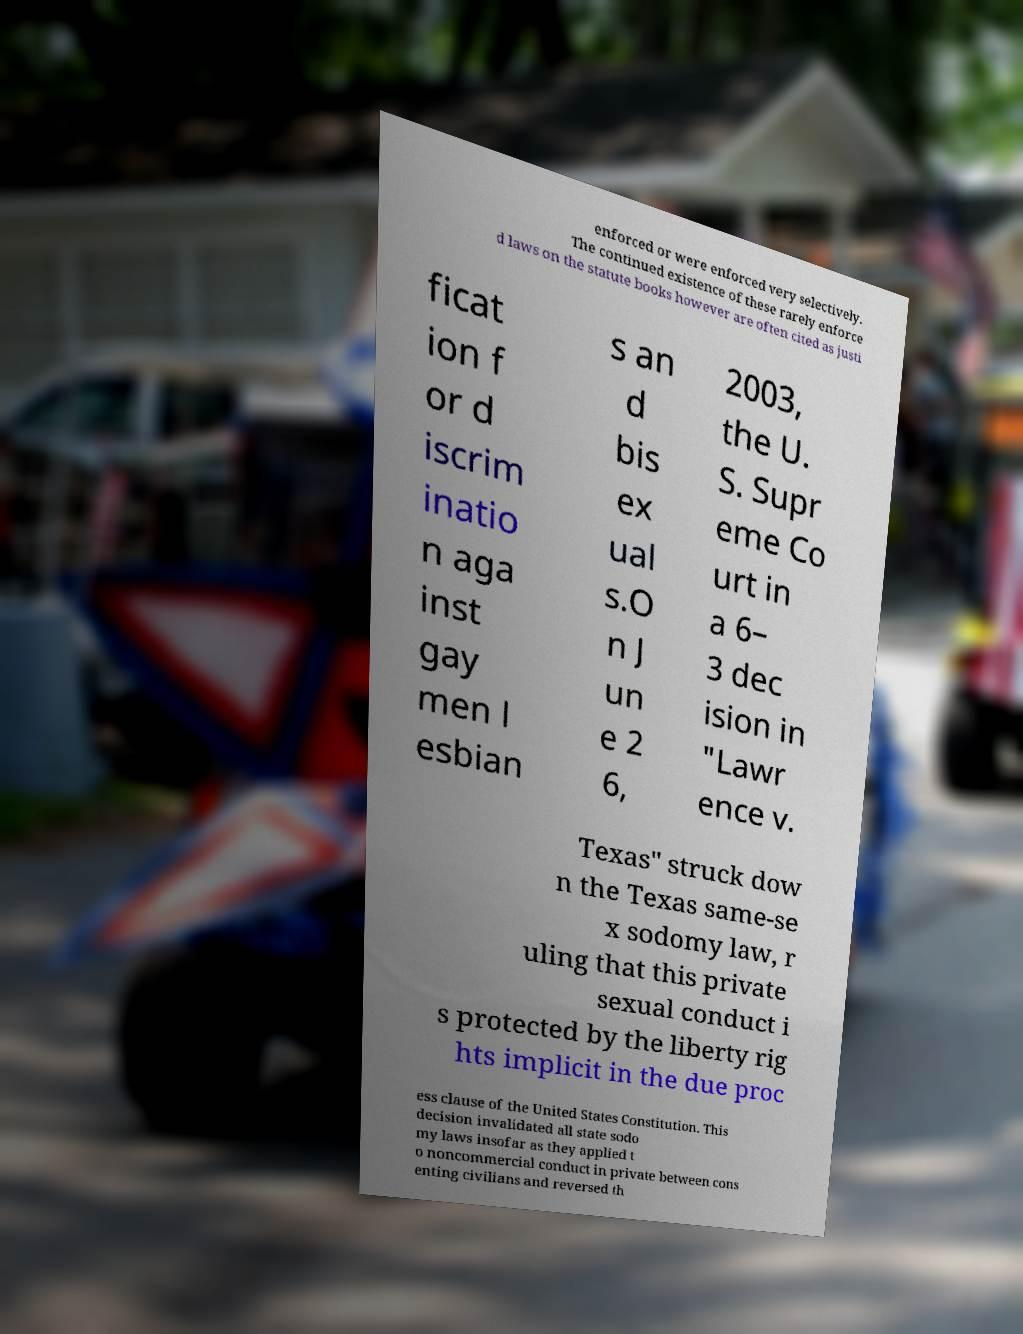There's text embedded in this image that I need extracted. Can you transcribe it verbatim? enforced or were enforced very selectively. The continued existence of these rarely enforce d laws on the statute books however are often cited as justi ficat ion f or d iscrim inatio n aga inst gay men l esbian s an d bis ex ual s.O n J un e 2 6, 2003, the U. S. Supr eme Co urt in a 6– 3 dec ision in "Lawr ence v. Texas" struck dow n the Texas same-se x sodomy law, r uling that this private sexual conduct i s protected by the liberty rig hts implicit in the due proc ess clause of the United States Constitution. This decision invalidated all state sodo my laws insofar as they applied t o noncommercial conduct in private between cons enting civilians and reversed th 